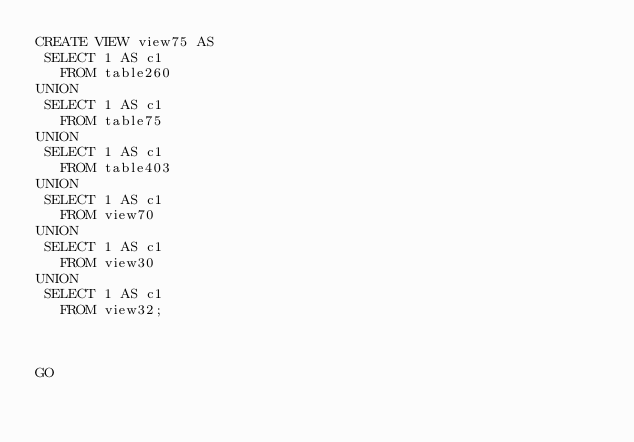Convert code to text. <code><loc_0><loc_0><loc_500><loc_500><_SQL_>CREATE VIEW view75 AS
 SELECT 1 AS c1
   FROM table260
UNION
 SELECT 1 AS c1
   FROM table75
UNION
 SELECT 1 AS c1
   FROM table403
UNION
 SELECT 1 AS c1
   FROM view70
UNION
 SELECT 1 AS c1
   FROM view30
UNION
 SELECT 1 AS c1
   FROM view32;



GO</code> 